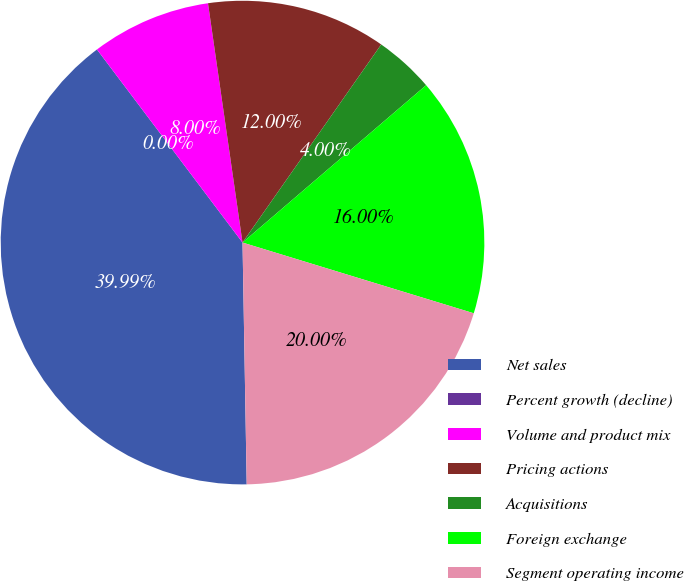Convert chart. <chart><loc_0><loc_0><loc_500><loc_500><pie_chart><fcel>Net sales<fcel>Percent growth (decline)<fcel>Volume and product mix<fcel>Pricing actions<fcel>Acquisitions<fcel>Foreign exchange<fcel>Segment operating income<nl><fcel>39.99%<fcel>0.0%<fcel>8.0%<fcel>12.0%<fcel>4.0%<fcel>16.0%<fcel>20.0%<nl></chart> 